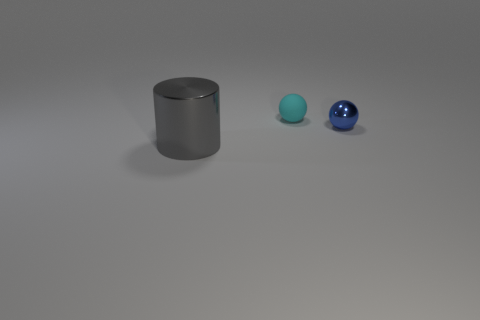What is the color of the metallic thing that is right of the tiny sphere left of the tiny ball that is to the right of the cyan sphere? The color of the metallic cylinder positioned to the right of the small, blue sphere, which is left of the slightly larger blue ball, and to the right of the cyan sphere, is gray with a metallic finish. Its coloration and finish give it a distinctive, reflective surface characteristic of metal objects. 